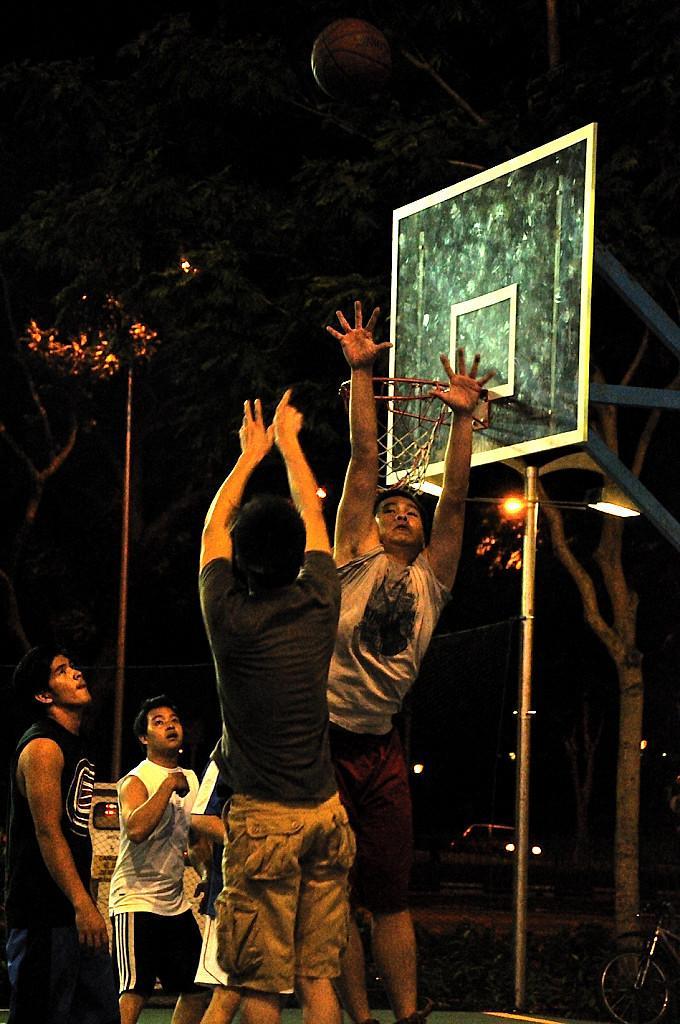Can you describe this image briefly? In this picture, we see two men are jumping and they are trying to catch the ball. Behind them, we see men are standing. I think they might be playing the basketball. On the right side, we see the street light and a basket. There are trees and lights in the background. This picture is blurred in the background. 